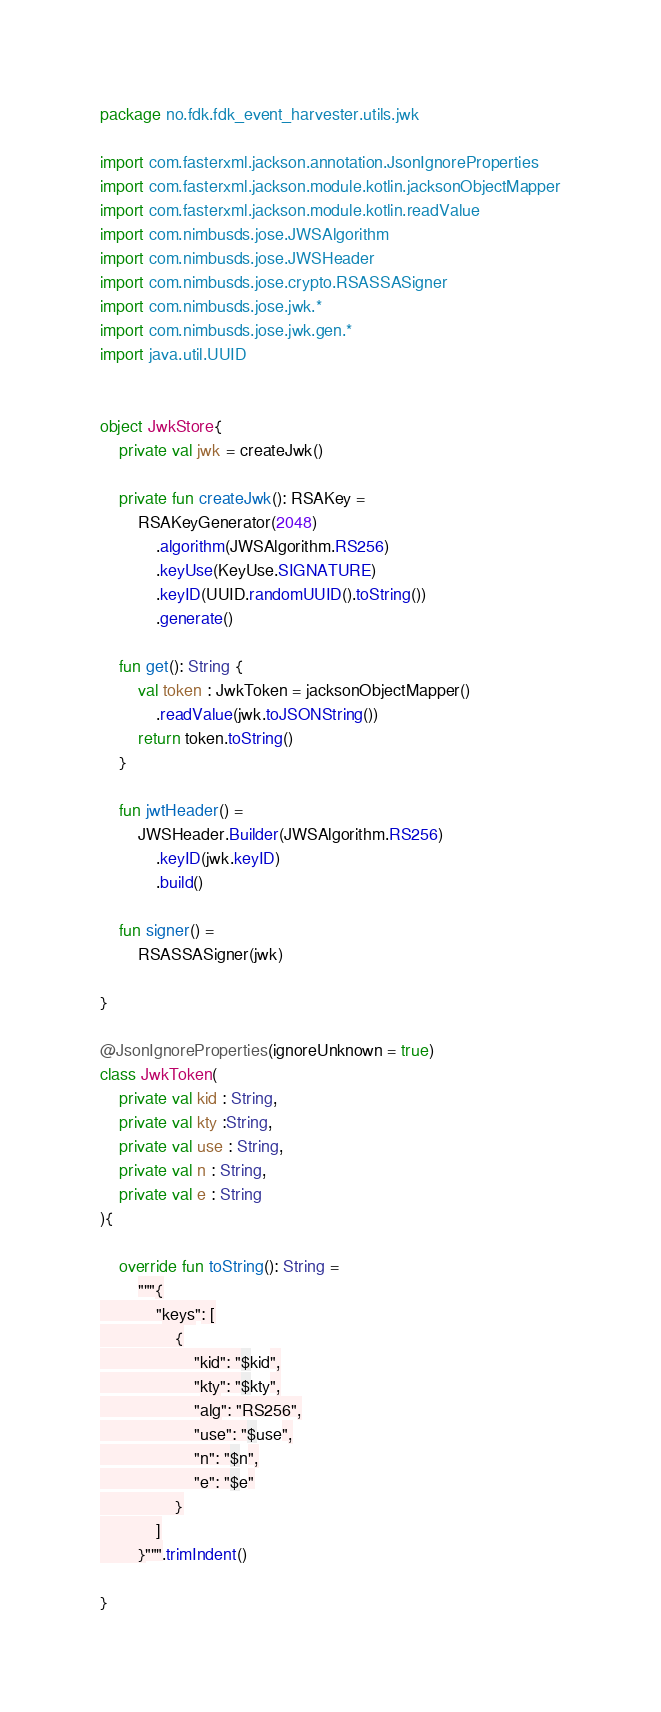Convert code to text. <code><loc_0><loc_0><loc_500><loc_500><_Kotlin_>package no.fdk.fdk_event_harvester.utils.jwk

import com.fasterxml.jackson.annotation.JsonIgnoreProperties
import com.fasterxml.jackson.module.kotlin.jacksonObjectMapper
import com.fasterxml.jackson.module.kotlin.readValue
import com.nimbusds.jose.JWSAlgorithm
import com.nimbusds.jose.JWSHeader
import com.nimbusds.jose.crypto.RSASSASigner
import com.nimbusds.jose.jwk.*
import com.nimbusds.jose.jwk.gen.*
import java.util.UUID


object JwkStore{
    private val jwk = createJwk()

    private fun createJwk(): RSAKey =
        RSAKeyGenerator(2048)
            .algorithm(JWSAlgorithm.RS256)
            .keyUse(KeyUse.SIGNATURE)
            .keyID(UUID.randomUUID().toString())
            .generate()

    fun get(): String {
        val token : JwkToken = jacksonObjectMapper()
            .readValue(jwk.toJSONString())
        return token.toString()
    }

    fun jwtHeader() =
        JWSHeader.Builder(JWSAlgorithm.RS256)
            .keyID(jwk.keyID)
            .build()

    fun signer() =
        RSASSASigner(jwk)

}

@JsonIgnoreProperties(ignoreUnknown = true)
class JwkToken(
    private val kid : String,
    private val kty :String,
    private val use : String,
    private val n : String,
    private val e : String
){

    override fun toString(): String =
        """{
            "keys": [
                {
                    "kid": "$kid",
                    "kty": "$kty",
                    "alg": "RS256",
                    "use": "$use",
                    "n": "$n",
                    "e": "$e"
                }
            ]
        }""".trimIndent()

}
</code> 